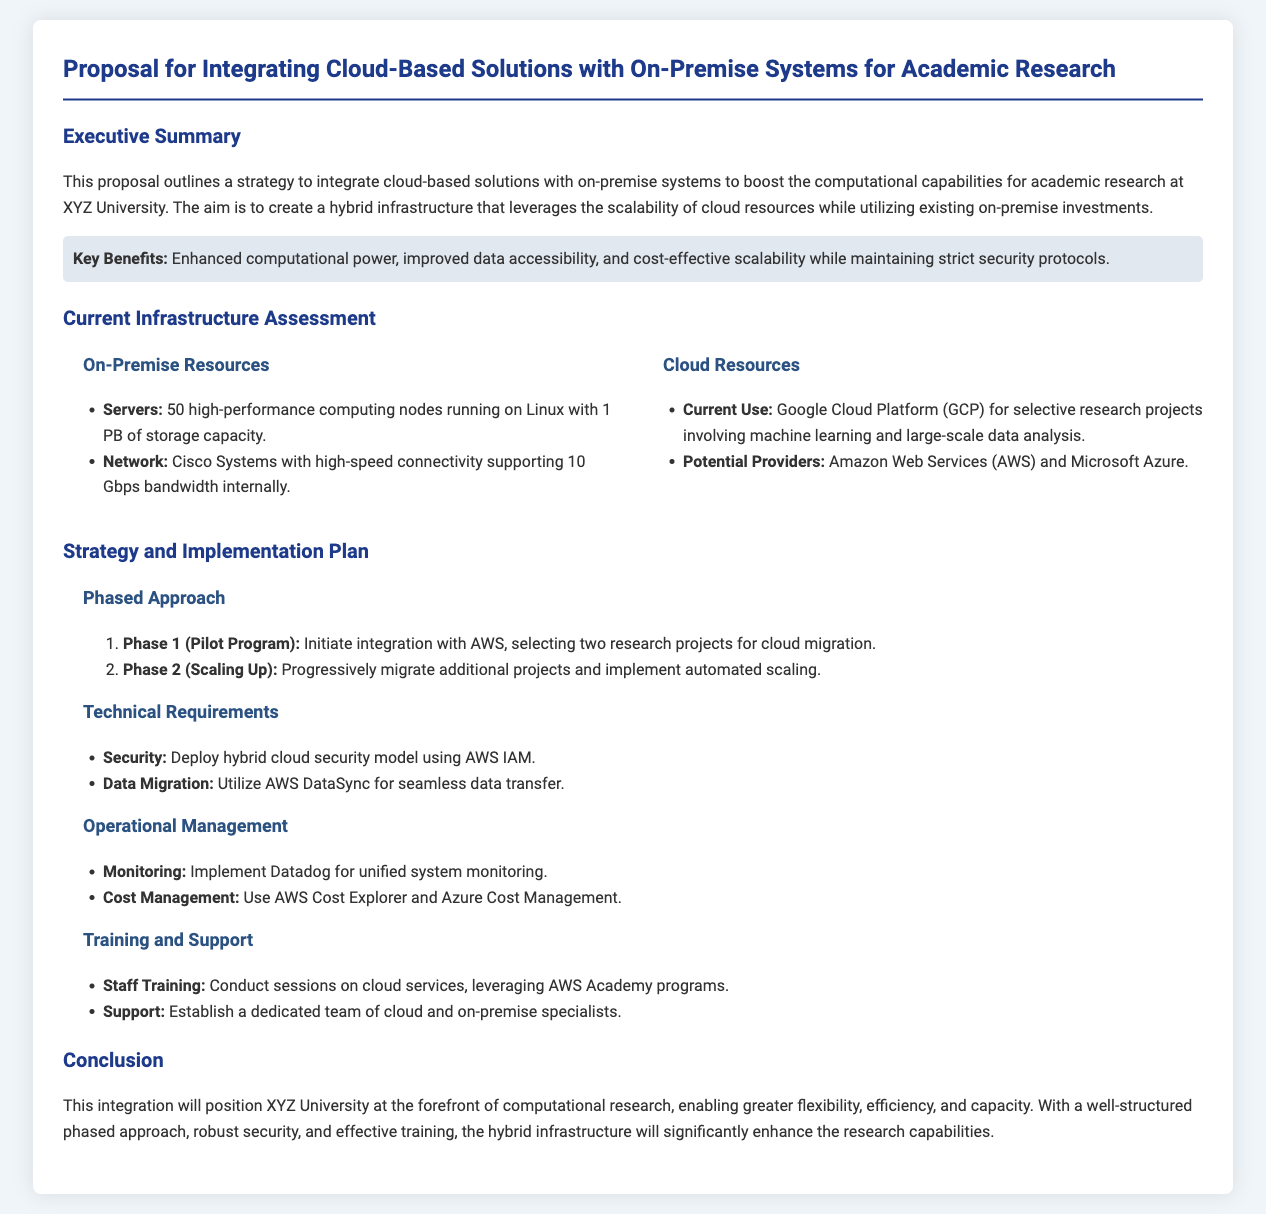what is the title of the proposal? The title of the proposal is stated at the beginning of the document.
Answer: Proposal for Integrating Cloud-Based Solutions with On-Premise Systems for Academic Research how many high-performance computing nodes are mentioned? The document specifies the number of high-performance computing nodes in the on-premise resources section.
Answer: 50 which cloud platform is currently being used for research projects at XYZ University? The current cloud platform for selective research projects is mentioned in the cloud resources section.
Answer: Google Cloud Platform what is the first phase of the implementation plan? The first phase of the implementation plan is detailed in the strategy section.
Answer: Phase 1 (Pilot Program) name one security measure proposed for the hybrid cloud model. The document lists security measures under the technical requirements section.
Answer: Deploy hybrid cloud security model using AWS IAM what is one tool mentioned for cost management? The document lists tools for operational management, including cost management.
Answer: AWS Cost Explorer how will the integration affect the computational capabilities at XYZ University? The document outlines the anticipated outcomes in the conclusion section.
Answer: Enhance research capabilities what initiative will be used for staff training? The document specifies an initiative for staff training within the training and support section.
Answer: AWS Academy programs 